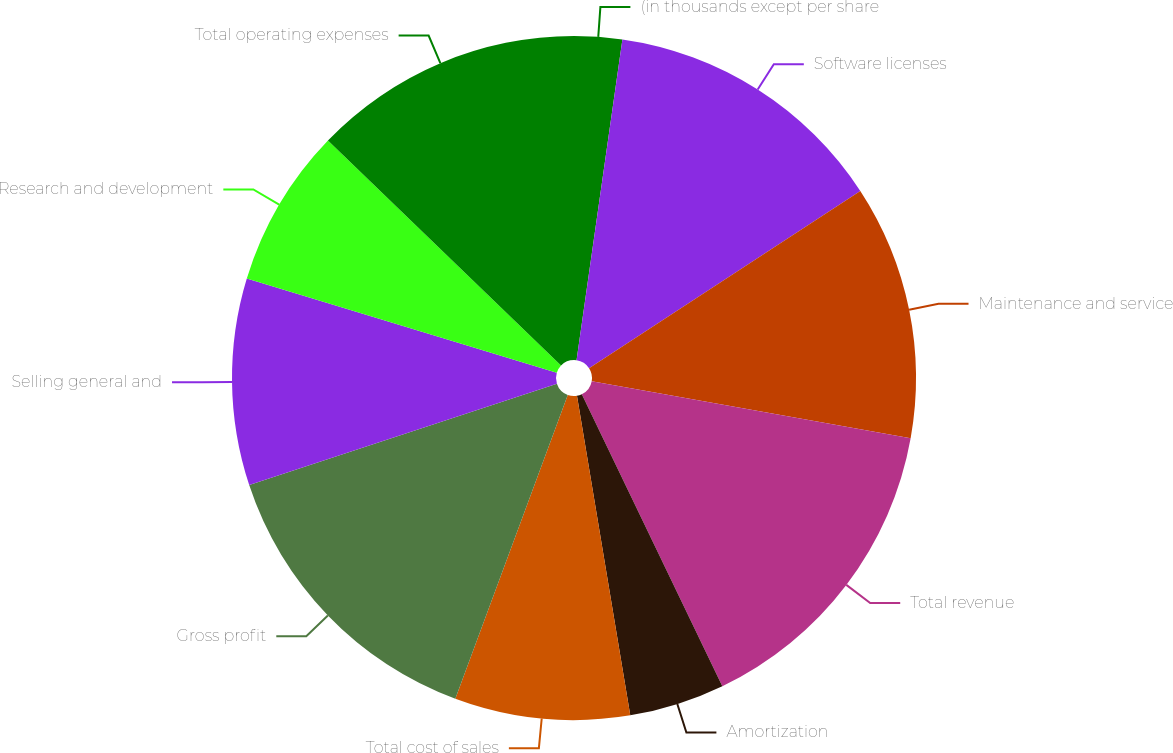Convert chart. <chart><loc_0><loc_0><loc_500><loc_500><pie_chart><fcel>(in thousands except per share<fcel>Software licenses<fcel>Maintenance and service<fcel>Total revenue<fcel>Amortization<fcel>Total cost of sales<fcel>Gross profit<fcel>Selling general and<fcel>Research and development<fcel>Total operating expenses<nl><fcel>2.26%<fcel>13.53%<fcel>12.03%<fcel>15.04%<fcel>4.51%<fcel>8.27%<fcel>14.29%<fcel>9.77%<fcel>7.52%<fcel>12.78%<nl></chart> 